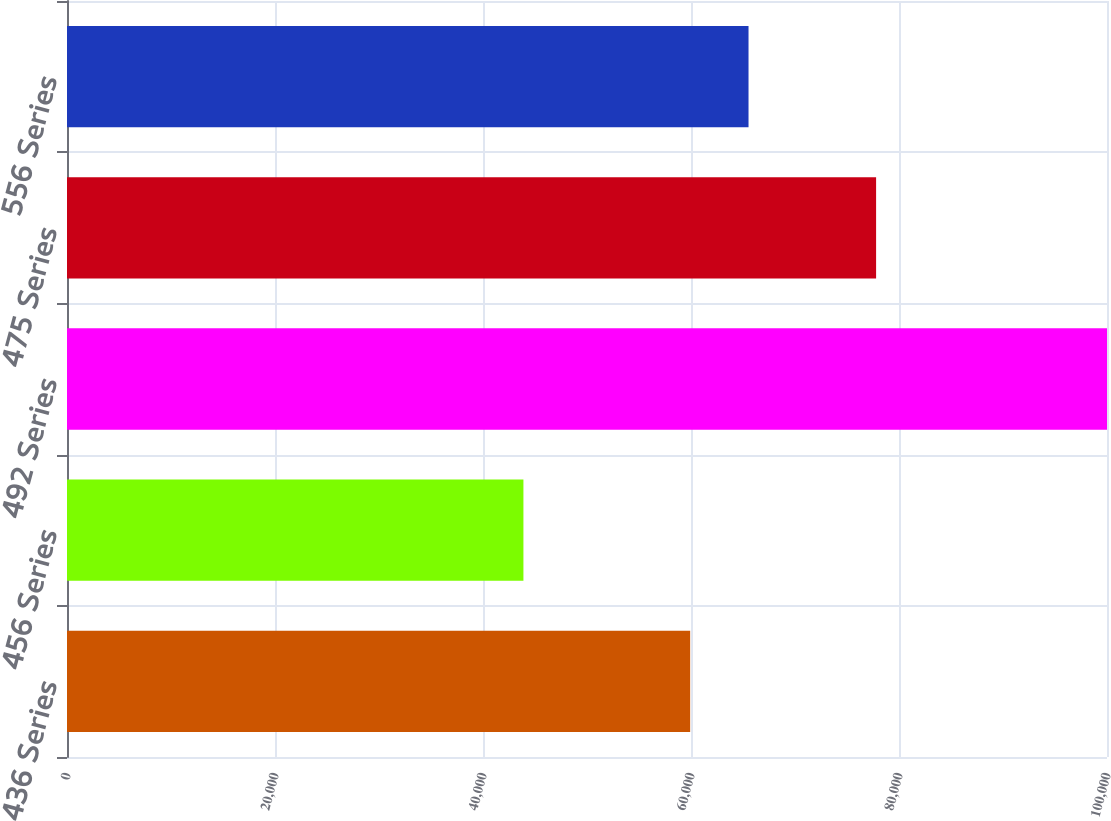Convert chart. <chart><loc_0><loc_0><loc_500><loc_500><bar_chart><fcel>436 Series<fcel>456 Series<fcel>492 Series<fcel>475 Series<fcel>556 Series<nl><fcel>59920<fcel>43887<fcel>100000<fcel>77798<fcel>65531.3<nl></chart> 